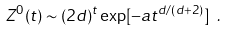<formula> <loc_0><loc_0><loc_500><loc_500>Z ^ { 0 } ( t ) \sim ( 2 d ) ^ { t } \exp [ - a t ^ { d / ( d + 2 ) } ] \ .</formula> 